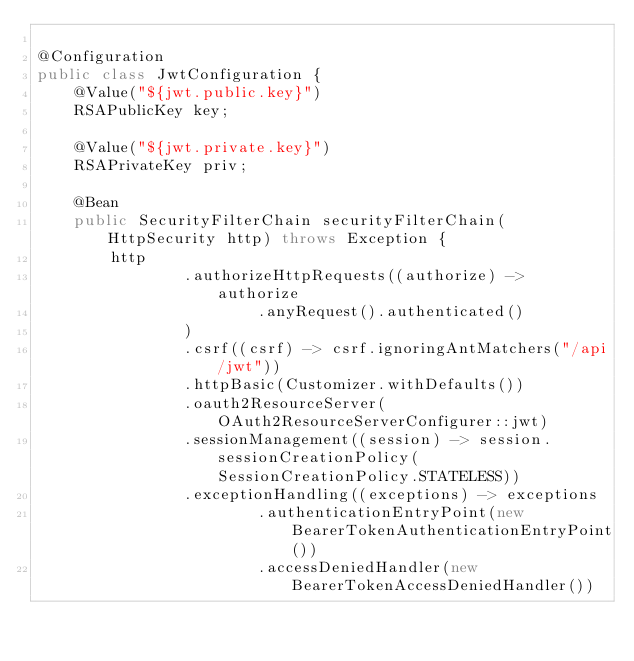<code> <loc_0><loc_0><loc_500><loc_500><_Java_>
@Configuration
public class JwtConfiguration {
    @Value("${jwt.public.key}")
    RSAPublicKey key;

    @Value("${jwt.private.key}")
    RSAPrivateKey priv;

    @Bean
    public SecurityFilterChain securityFilterChain(HttpSecurity http) throws Exception {
        http
                .authorizeHttpRequests((authorize) -> authorize
                        .anyRequest().authenticated()
                )
                .csrf((csrf) -> csrf.ignoringAntMatchers("/api/jwt"))
                .httpBasic(Customizer.withDefaults())
                .oauth2ResourceServer(OAuth2ResourceServerConfigurer::jwt)
                .sessionManagement((session) -> session.sessionCreationPolicy(SessionCreationPolicy.STATELESS))
                .exceptionHandling((exceptions) -> exceptions
                        .authenticationEntryPoint(new BearerTokenAuthenticationEntryPoint())
                        .accessDeniedHandler(new BearerTokenAccessDeniedHandler())</code> 